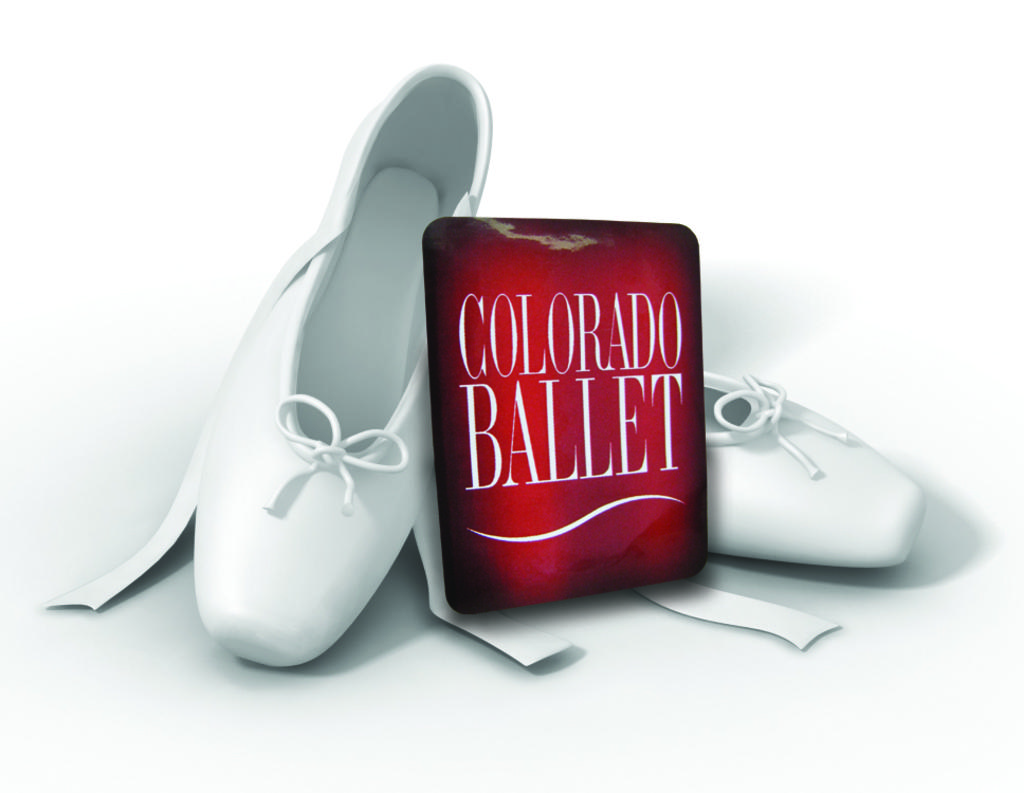What type of footwear is visible in the image? There are shoes in the image. What is written or displayed on the board in the image? There is a board with text in the image. What color is the background of the image? The background of the image is white. How many weeks does it take for the shoes to end their journey in the image? The image does not provide information about the shoes' journey or duration, so it is not possible to answer that question. What type of tin is present in the image? There is no tin present in the image. 